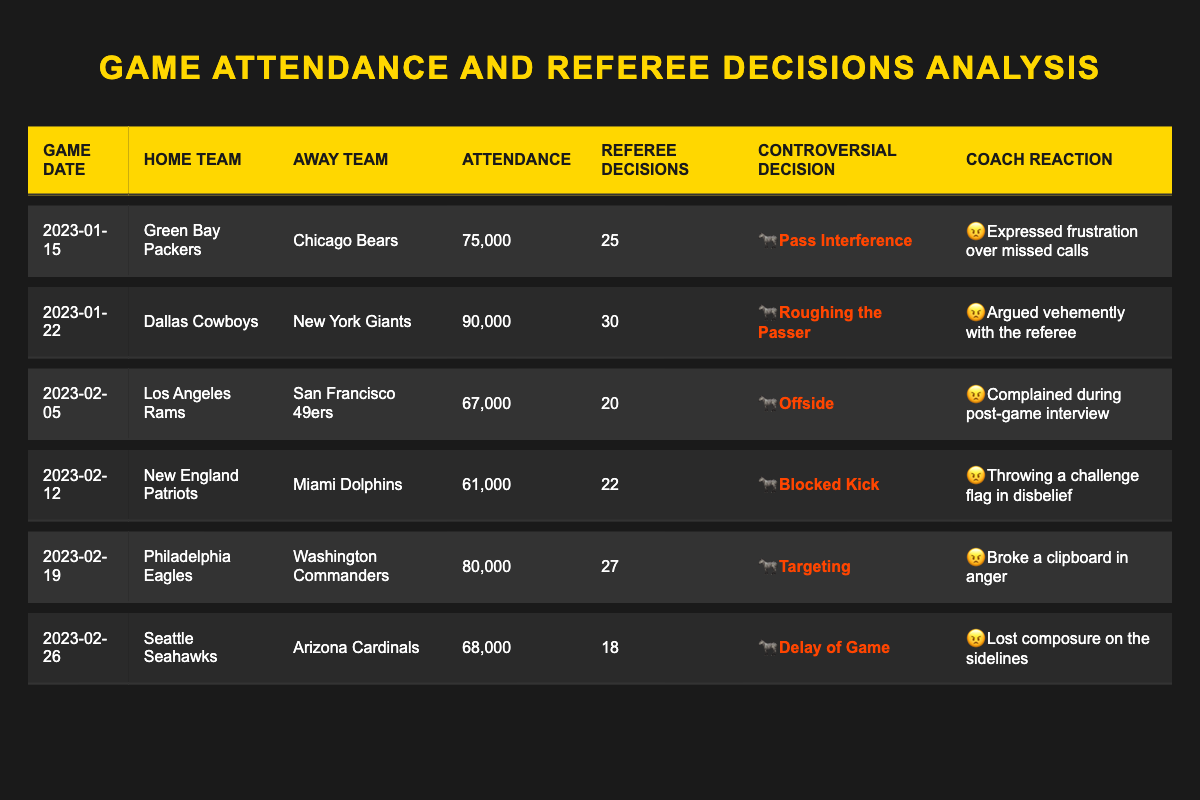What was the highest game attendance recorded in the table? The highest attendance in the table is 90,000, which occurred during the game between the Dallas Cowboys and New York Giants on January 22, 2023.
Answer: 90,000 Which game had the most referee decisions? The game with the most referee decisions is between the Dallas Cowboys and New York Giants, with 30 decisions made on January 22, 2023.
Answer: 30 What was the controversial decision for the game on February 5, 2023? On February 5, 2023, the controversial decision in the game between the Los Angeles Rams and San Francisco 49ers was "Offside."
Answer: Offside Did any coach express frustration over missed calls? Yes, the coach of the Green Bay Packers expressed frustration over missed calls during the game on January 15, 2023.
Answer: Yes What was the average attendance of the games listed? The total attendance is 450,000 across 6 games, so average attendance is 450,000 / 6 = 75,000.
Answer: 75,000 Which coach reacted by throwing a challenge flag? The coach who threw a challenge flag in disbelief was from the New England Patriots during the game against the Miami Dolphins on February 12, 2023.
Answer: New England Patriots How many games had "Targeting" as a controversial decision? Only one game had "Targeting" as a controversial decision, which was played between the Philadelphia Eagles and Washington Commanders on February 19, 2023.
Answer: 1 What is the total number of referee decisions made in all games? The total number of referee decisions is the sum of decisions in all games: 25 + 30 + 20 + 22 + 27 + 18 = 172.
Answer: 172 Did the Seattle Seahawks game have more or fewer controversial decisions than the average? The Seattle Seahawks game had 18 controversial decisions, which is fewer than the average of 25.33 from all games (172 / 6).
Answer: Fewer What was the coach's reaction in the game with the lowest attendance? In the game with the lowest attendance (61,000) on February 12, 2023, the coach from the New England Patriots reacted by throwing a challenge flag in disbelief.
Answer: Threw a challenge flag in disbelief 